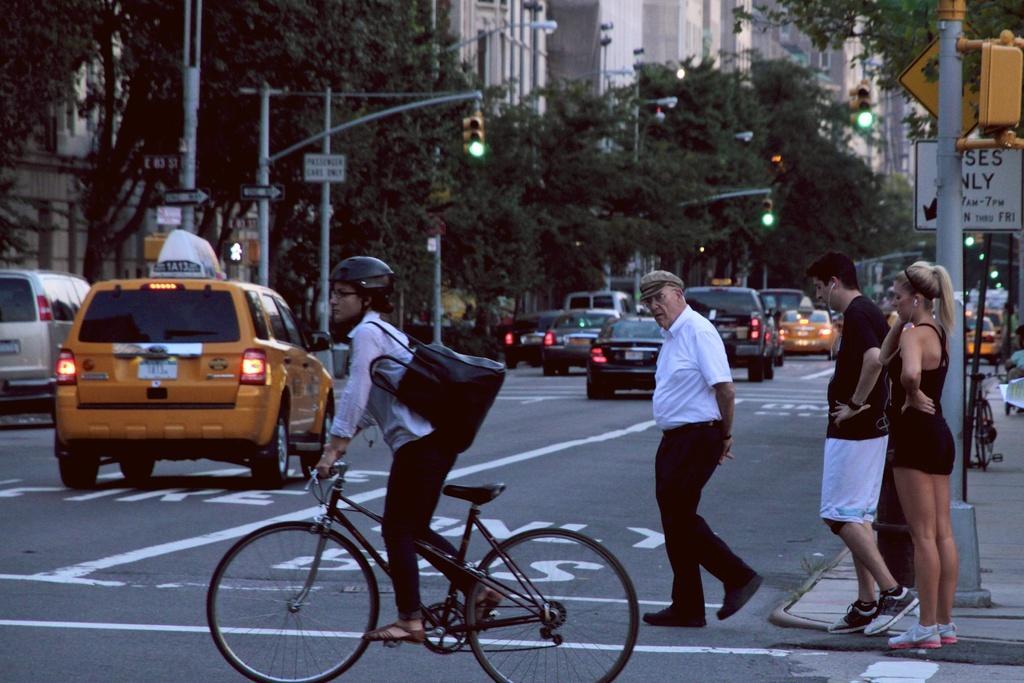How would you summarize this image in a sentence or two? As we can see in he image there are buildings, trees, traffic signal, cars, few people walking on road and a bicycle. 